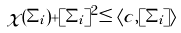<formula> <loc_0><loc_0><loc_500><loc_500>\chi ( \Sigma _ { i } ) + [ \Sigma _ { i } ] ^ { 2 } \leq \langle c , [ \Sigma _ { i } ] \rangle</formula> 